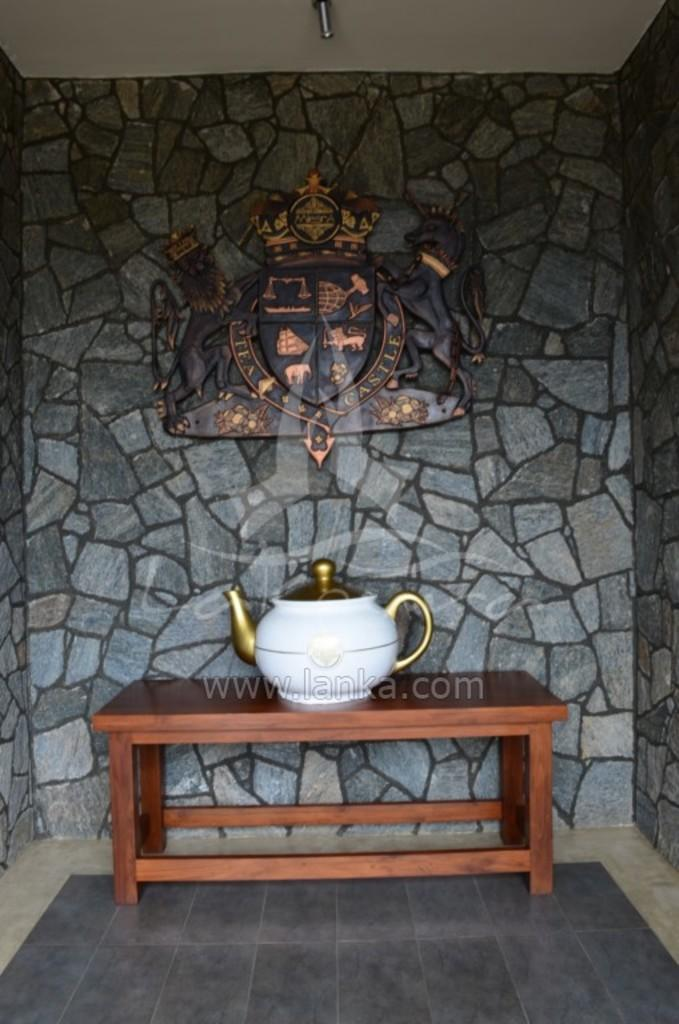What piece of furniture is present in the image? There is a table in the image. What is placed on the table? There is a kettle on the table. What type of surface is visible in the image? The image contains a floor. What architectural feature is present in the image? There is a wall in the image. What decorative item can be seen on the wall? There is a shield on the wall. Who is the manager of the system in the image? There is no system or manager present in the image. How many seats are available in the image? There are no seats present in the image. 